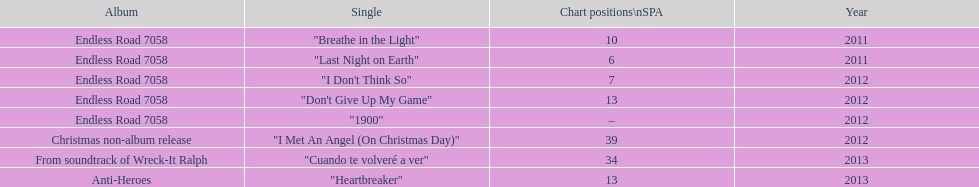Based on sales figures, what auryn album is the most popular? Endless Road 7058. 